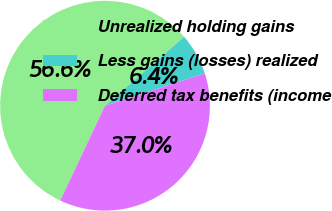Convert chart to OTSL. <chart><loc_0><loc_0><loc_500><loc_500><pie_chart><fcel>Unrealized holding gains<fcel>Less gains (losses) realized<fcel>Deferred tax benefits (income<nl><fcel>56.57%<fcel>6.42%<fcel>37.0%<nl></chart> 